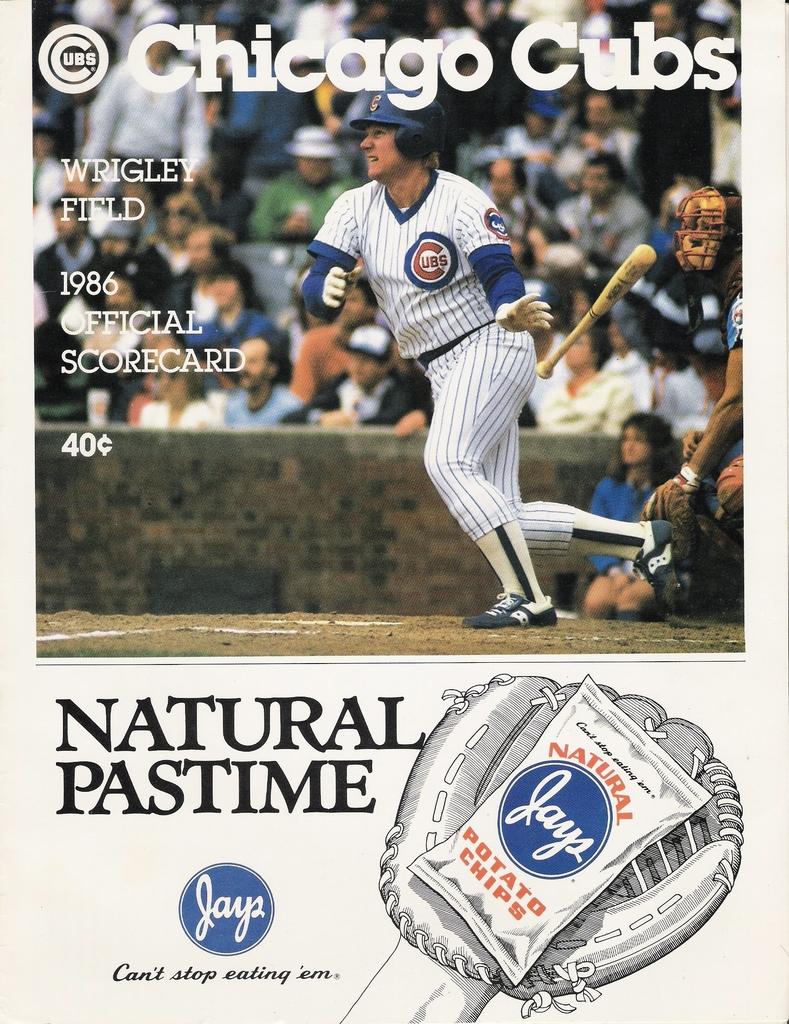What brand are the potato chips?
Ensure brevity in your answer.  Jays. 